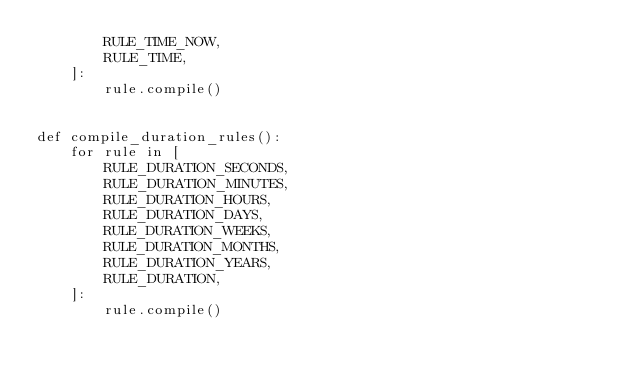<code> <loc_0><loc_0><loc_500><loc_500><_Python_>        RULE_TIME_NOW,
        RULE_TIME,
    ]:
        rule.compile()


def compile_duration_rules():
    for rule in [
        RULE_DURATION_SECONDS,
        RULE_DURATION_MINUTES,
        RULE_DURATION_HOURS,
        RULE_DURATION_DAYS,
        RULE_DURATION_WEEKS,
        RULE_DURATION_MONTHS,
        RULE_DURATION_YEARS,
        RULE_DURATION,
    ]:
        rule.compile()
</code> 